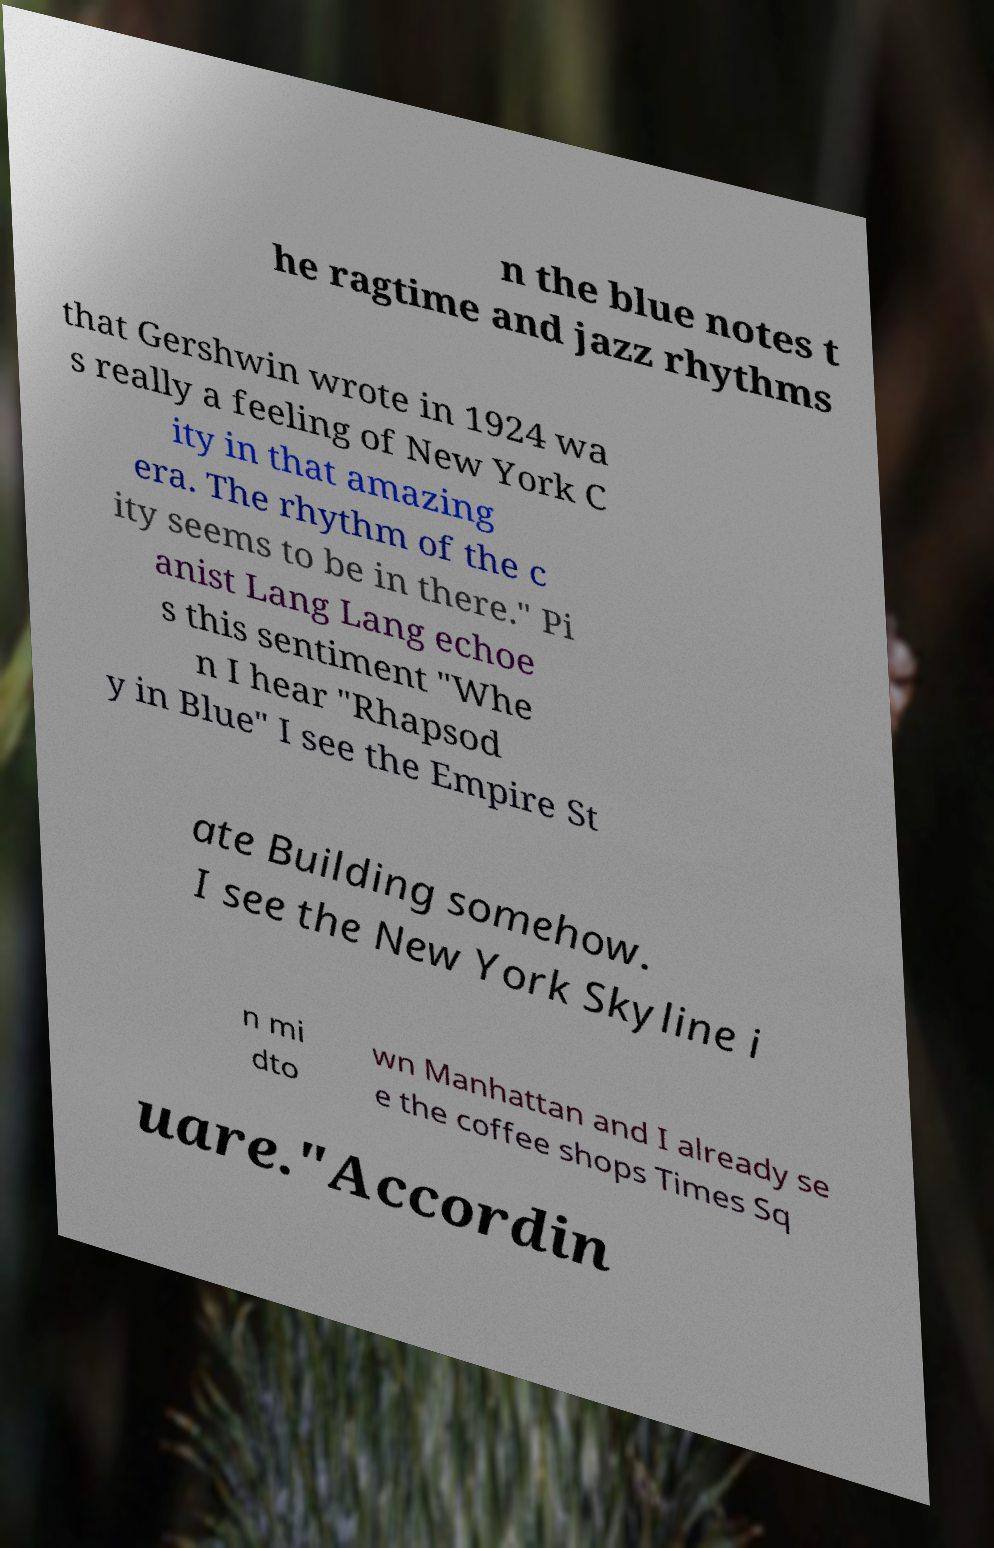Please read and relay the text visible in this image. What does it say? n the blue notes t he ragtime and jazz rhythms that Gershwin wrote in 1924 wa s really a feeling of New York C ity in that amazing era. The rhythm of the c ity seems to be in there." Pi anist Lang Lang echoe s this sentiment "Whe n I hear "Rhapsod y in Blue" I see the Empire St ate Building somehow. I see the New York Skyline i n mi dto wn Manhattan and I already se e the coffee shops Times Sq uare."Accordin 